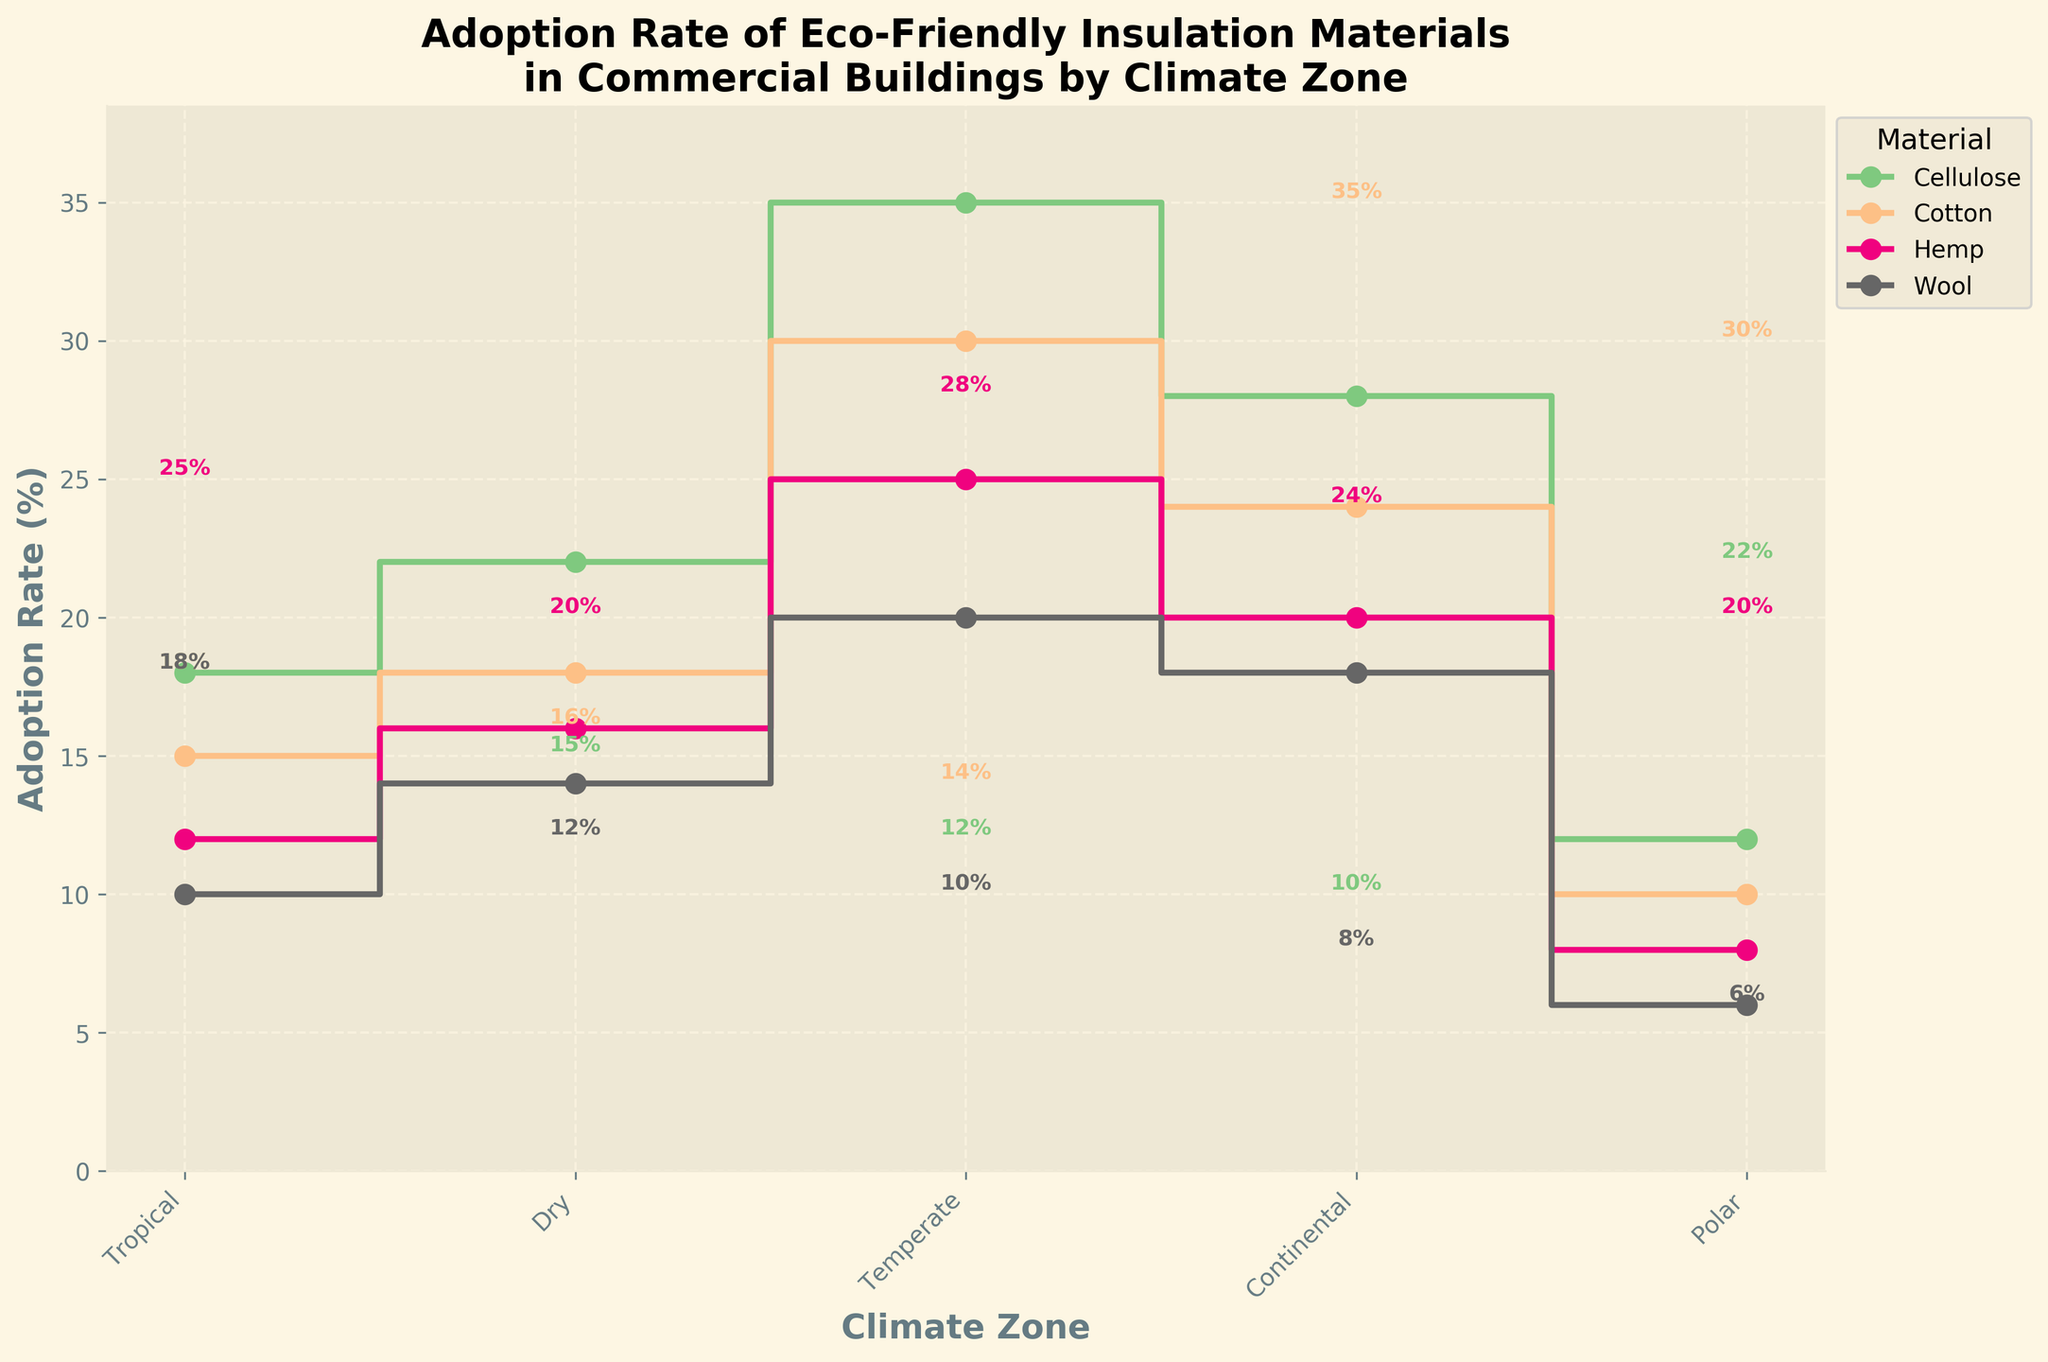what is the adoption rate of hemp in the tropical climate zone? To find the adoption rate of hemp in the tropical climate, locate the step line for hemp (which is colored distinctly) at the "Tropical" label on the x-axis. Read off the corresponding y-axis value.
Answer: 12% which material has the highest adoption rate in the temperate climate zone? In the temperate climate zone, examine the y-values of the step lines for each material. The material with the highest y-value is cellulose.
Answer: cellulose how much greater is the adoption rate of wool in the continental zone compared to the polar zone? Identify the adoption rates of wool in both the continental and polar zones from the y-axis. The adoption rate in the continental zone is 18%, and in the polar zone, it is 6%. Subtract the polar zone adoption rate from the continental zone adoption rate. 18% - 6% = 12%
Answer: 12% which material shows the greatest difference in adoption rates between the dry and polar climate zones? Compare the adoption rates of each material between the dry and polar zones. Calculate the differences for cellulose (22% - 12% = 10%), cotton (18% - 10% = 8%), hemp (16% - 8% = 8%), and wool (14% - 6% = 8%). The largest difference is for cellulose.
Answer: cellulose what observations can you make about the change in adoption rates of cotton across different climate zones? By observing the step line for cotton, it increases from the tropical zone (15%) to the temperate zone (30%) and then decreases through the continental (24%) to the polar zone (10%).
Answer: Initially increases and then decreases what is the average adoption rate for cellulose across all climate zones? Sum the adoption rates of cellulose (18% + 22% + 35% + 28% + 12%) and divide by the number of climate zones (5). The total is 115%, so the average is 115% / 5 = 23%.
Answer: 23% is there any climate zone where hemp has a higher adoption rate than cellulose? Compare the adoption rates of hemp and cellulose in each climate zone. In every zone, cellulose has a higher adoption rate than hemp.
Answer: No in which climate zone does cotton have the smallest adoption rate difference compared to cellulose? Calculate the differences in adoption rates between cotton and cellulose in each climate zone. Differences: Tropical (18% - 15% = 3%), Dry (22% - 18% = 4%), Temperate (35% - 30% = 5%), Continental (28% - 24% = 4%), Polar (12% - 10% = 2%). The smallest difference is in the tropical zone.
Answer: tropical based on the plot, which material's adoption rate changes most consistently across the climate zones? By observing all step lines, cellulose shows a generally consistent increase in adoption rates across most climate zones, without many fluctuations.
Answer: cellulose 